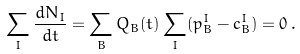Convert formula to latex. <formula><loc_0><loc_0><loc_500><loc_500>\sum _ { I } \frac { d N _ { I } } { d t } = \sum _ { B } Q _ { B } ( t ) \sum _ { I } ( p _ { B } ^ { I } - c _ { B } ^ { I } ) = 0 \, .</formula> 